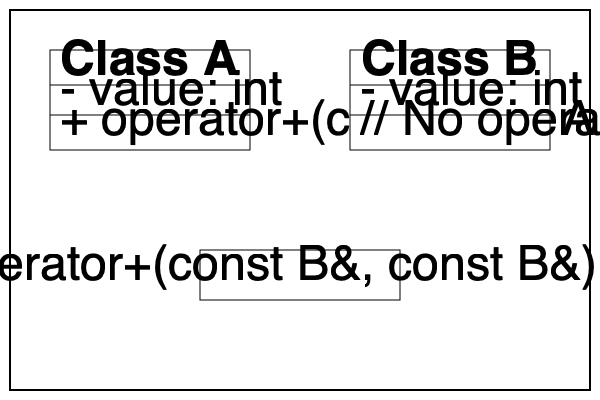Based on the UML class diagram, which approach to operator overloading is used for Class A and Class B respectively? To determine the approach used for operator overloading in each class, we need to analyze the UML diagram:

1. Class A:
   - It has a member function `operator+(const A&): A`
   - This indicates that the addition operator is implemented as a member function of Class A

2. Class B:
   - It does not have any operator overloading function within the class
   - There is a separate function `operator+(const B&, const B&): B` outside the class
   - This indicates that the addition operator for Class B is implemented as a non-member function

3. Member function approach (Class A):
   - Allows access to private members of the left-hand operand
   - Cannot be used for operations where the left-hand operand is not an object of the class
   - Syntax: `a + b` is equivalent to `a.operator+(b)`

4. Non-member function approach (Class B):
   - Requires both operands to be passed as parameters
   - Can be used for operations where either operand is not an object of the class
   - Often declared as a friend function to access private members
   - Syntax: `a + b` is equivalent to `operator+(a, b)`

Therefore, Class A uses the member function approach, while Class B uses the non-member function approach for operator overloading.
Answer: Class A: Member function, Class B: Non-member function 